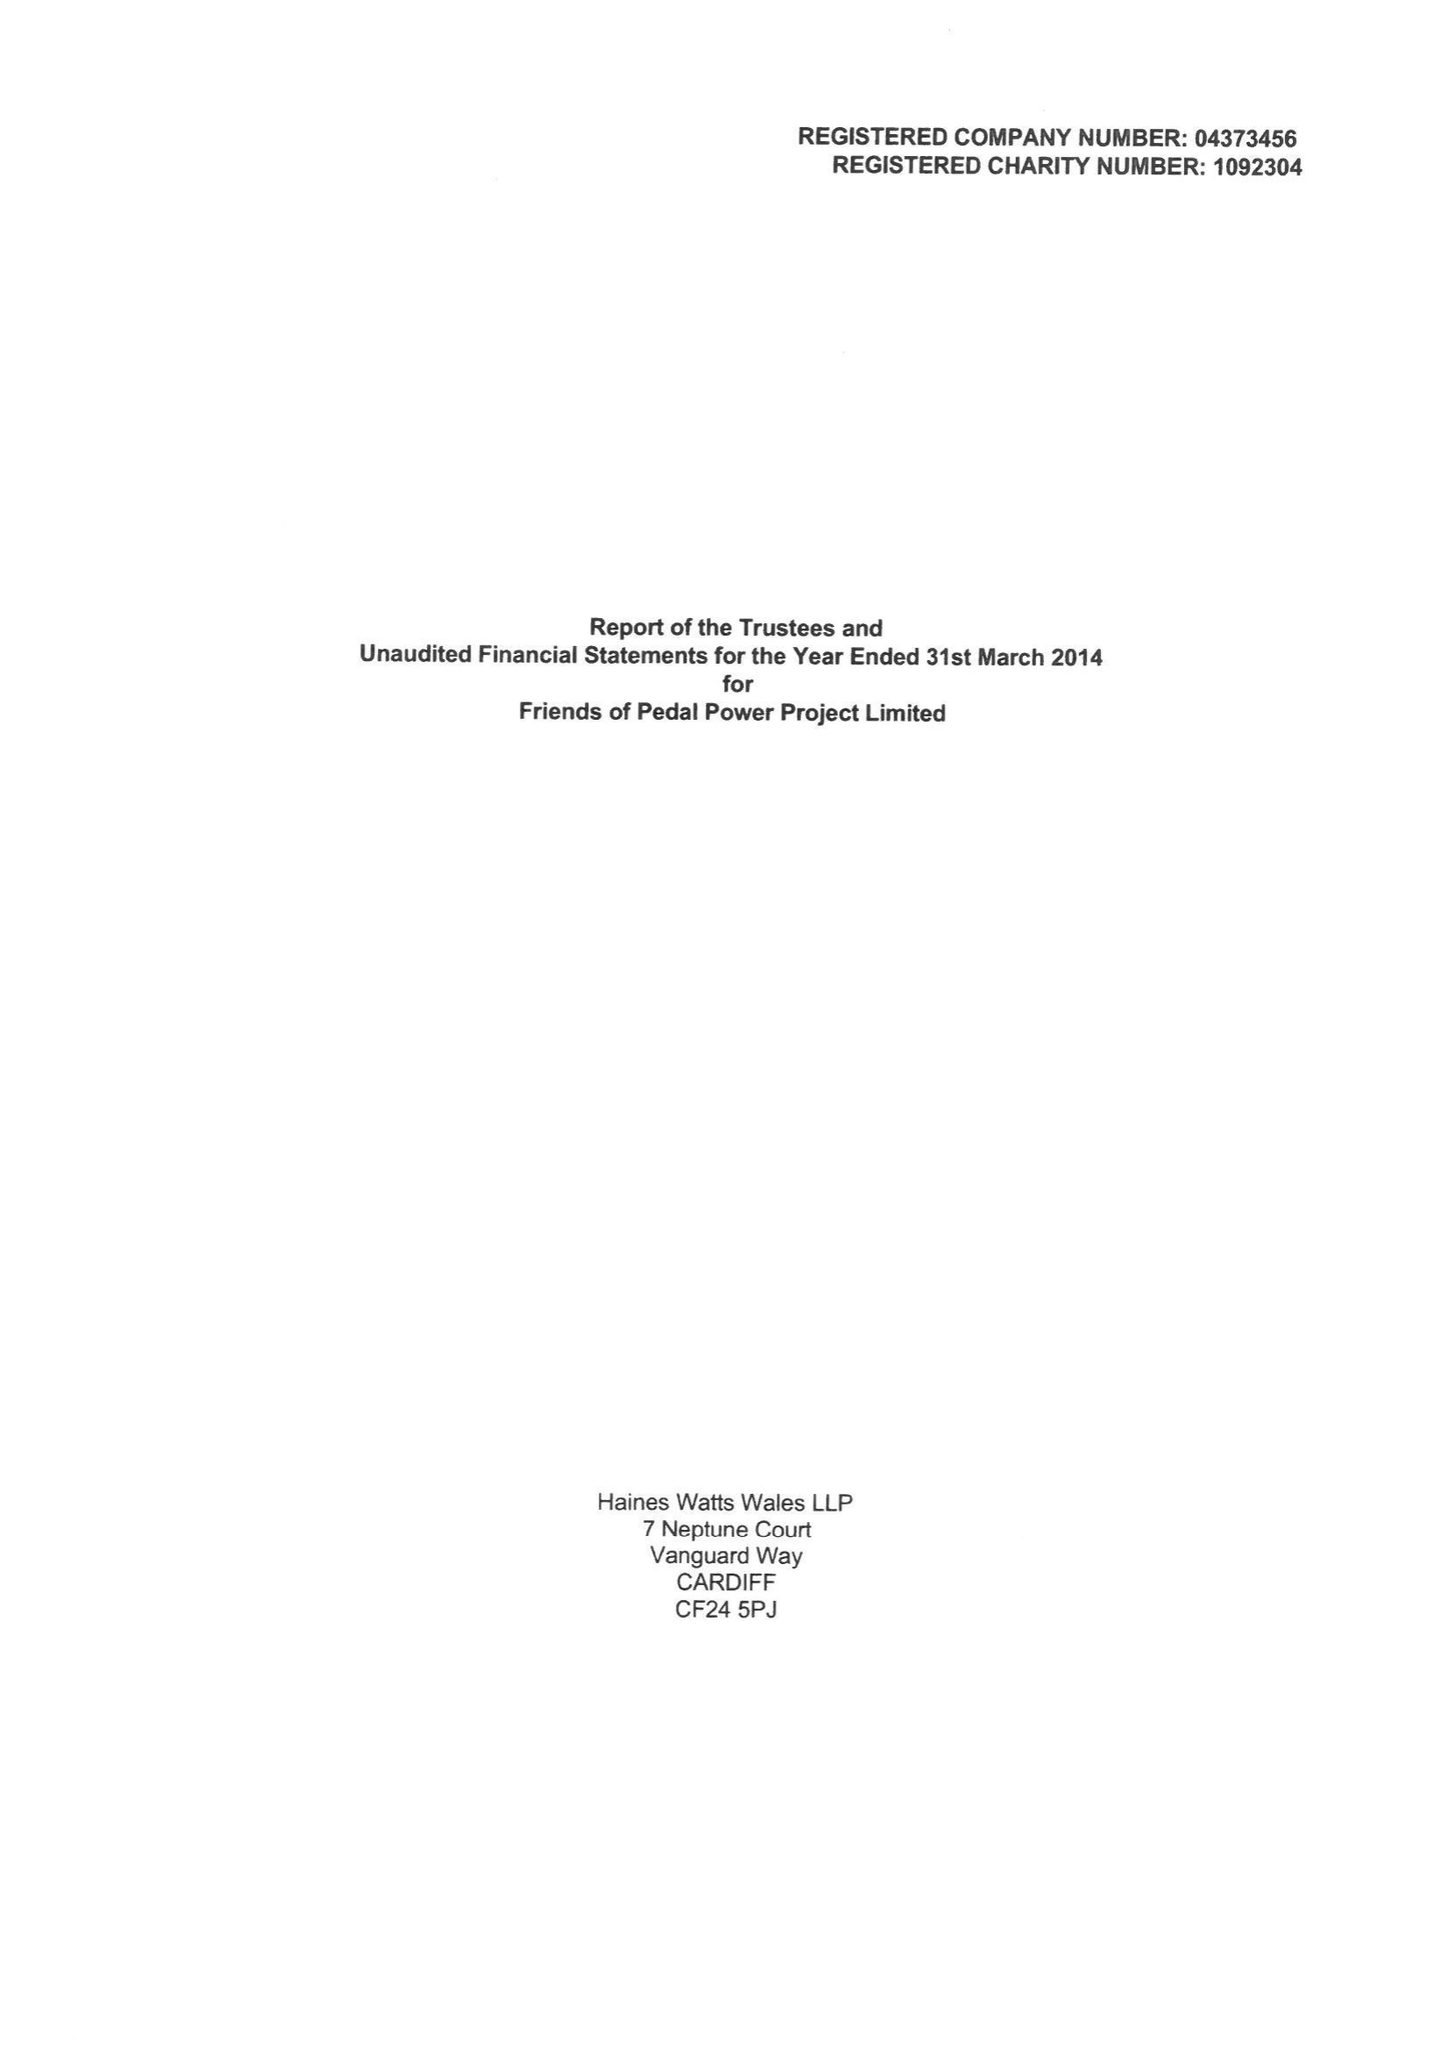What is the value for the address__post_town?
Answer the question using a single word or phrase. CARDIFF 